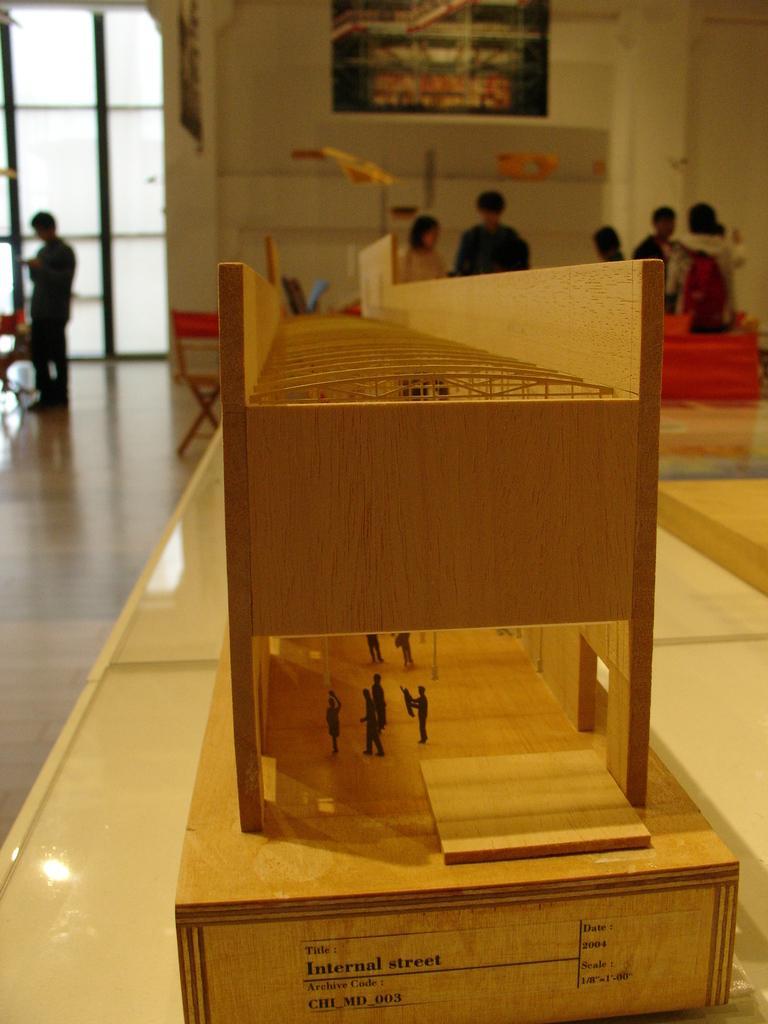In one or two sentences, can you explain what this image depicts? In this image we can see floor, table, wooden grill, walls and persons on the floor. 